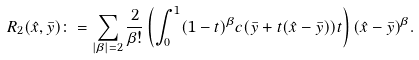<formula> <loc_0><loc_0><loc_500><loc_500>R _ { 2 } ( \hat { x } , \bar { y } ) \colon = \sum _ { | \beta | = 2 } \frac { 2 } { \beta ! } \left ( \int _ { 0 } ^ { 1 } ( 1 - t ) ^ { \beta } c ( \bar { y } + t ( \hat { x } - \bar { y } ) ) t \right ) ( \hat { x } - \bar { y } ) ^ { \beta } .</formula> 